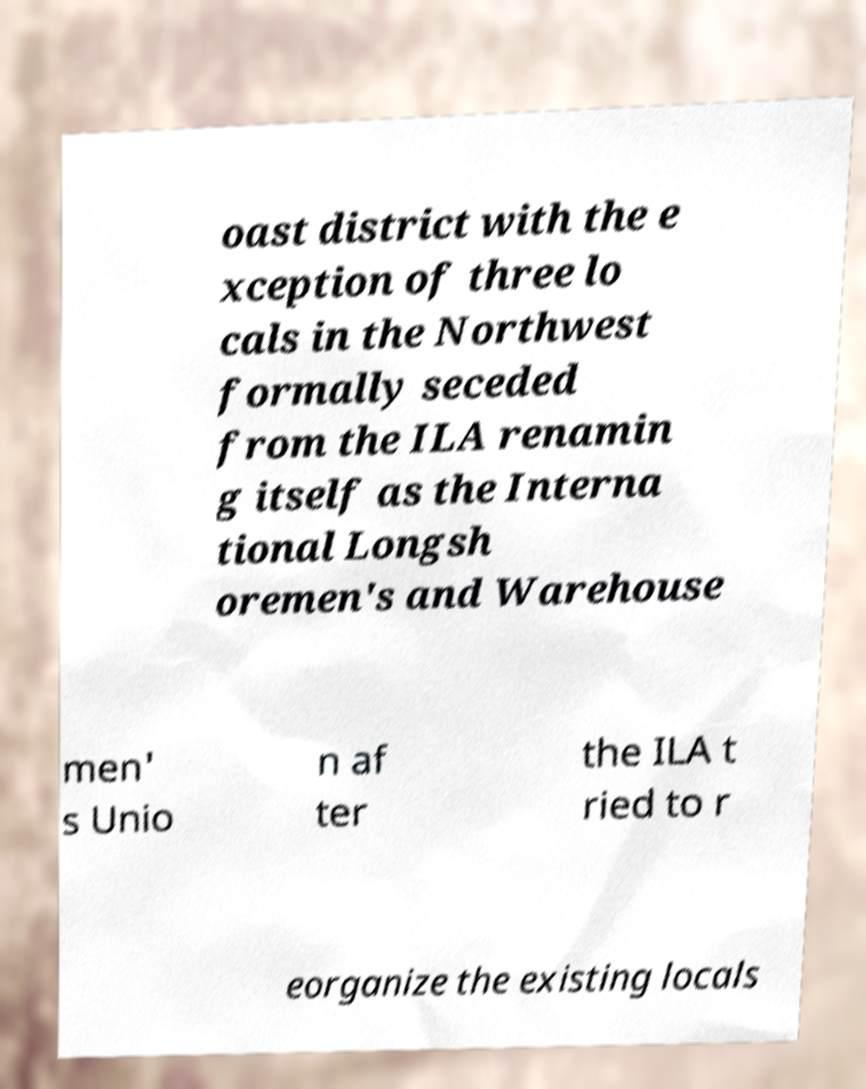Please identify and transcribe the text found in this image. oast district with the e xception of three lo cals in the Northwest formally seceded from the ILA renamin g itself as the Interna tional Longsh oremen's and Warehouse men' s Unio n af ter the ILA t ried to r eorganize the existing locals 